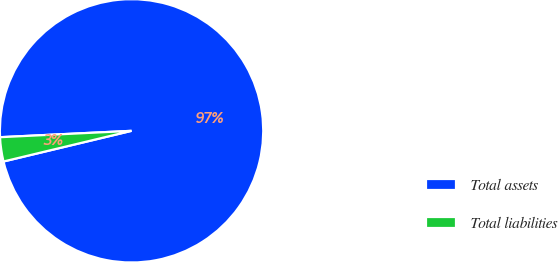<chart> <loc_0><loc_0><loc_500><loc_500><pie_chart><fcel>Total assets<fcel>Total liabilities<nl><fcel>97.03%<fcel>2.97%<nl></chart> 